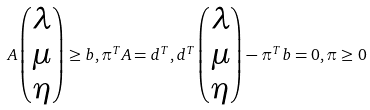<formula> <loc_0><loc_0><loc_500><loc_500>A \begin{pmatrix} \lambda \\ \mu \\ \eta \end{pmatrix} \geq b , \pi ^ { T } A = d ^ { T } , d ^ { T } \begin{pmatrix} \lambda \\ \mu \\ \eta \end{pmatrix} - \pi ^ { T } b = 0 , \pi \geq 0</formula> 